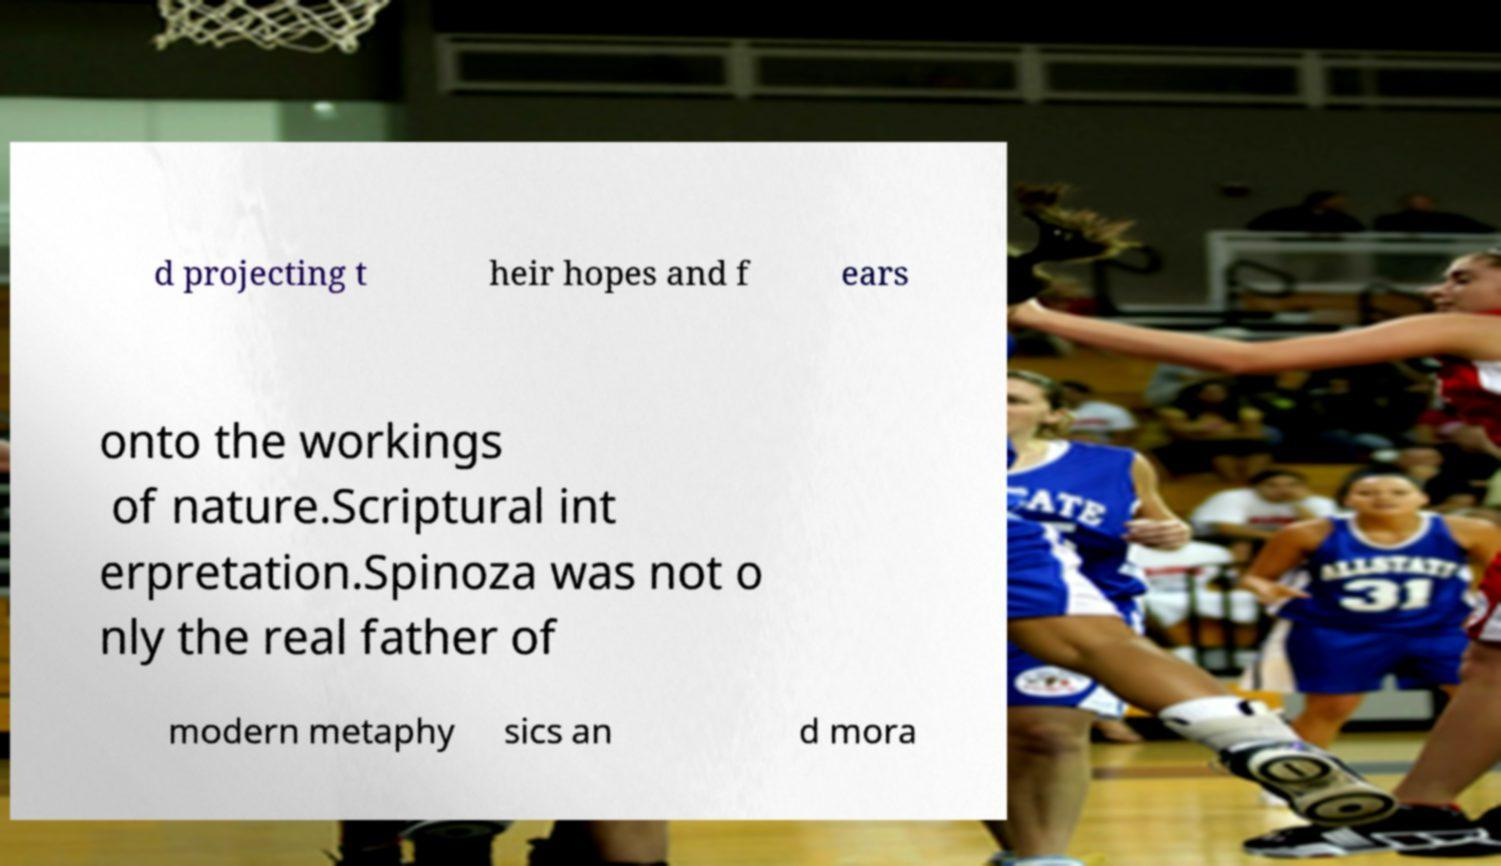Please read and relay the text visible in this image. What does it say? d projecting t heir hopes and f ears onto the workings of nature.Scriptural int erpretation.Spinoza was not o nly the real father of modern metaphy sics an d mora 